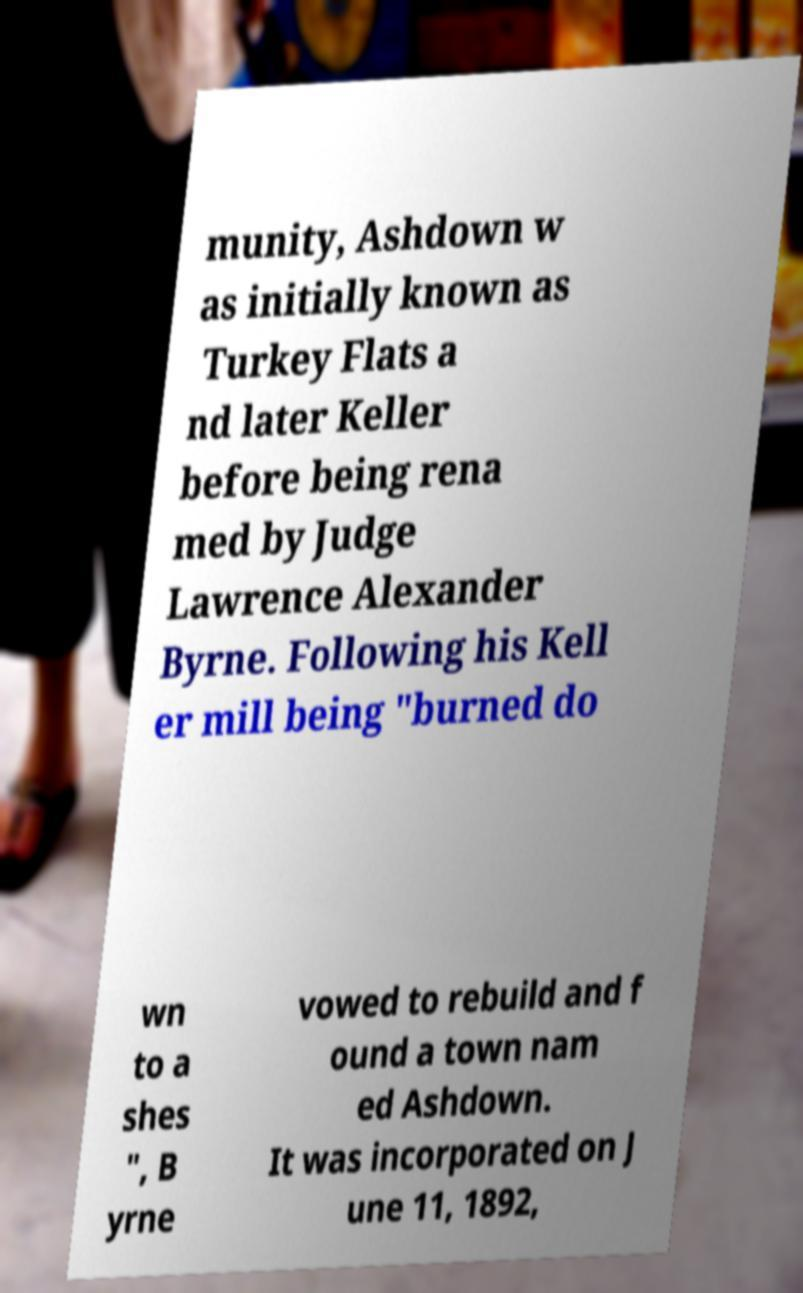Can you read and provide the text displayed in the image?This photo seems to have some interesting text. Can you extract and type it out for me? munity, Ashdown w as initially known as Turkey Flats a nd later Keller before being rena med by Judge Lawrence Alexander Byrne. Following his Kell er mill being "burned do wn to a shes ", B yrne vowed to rebuild and f ound a town nam ed Ashdown. It was incorporated on J une 11, 1892, 